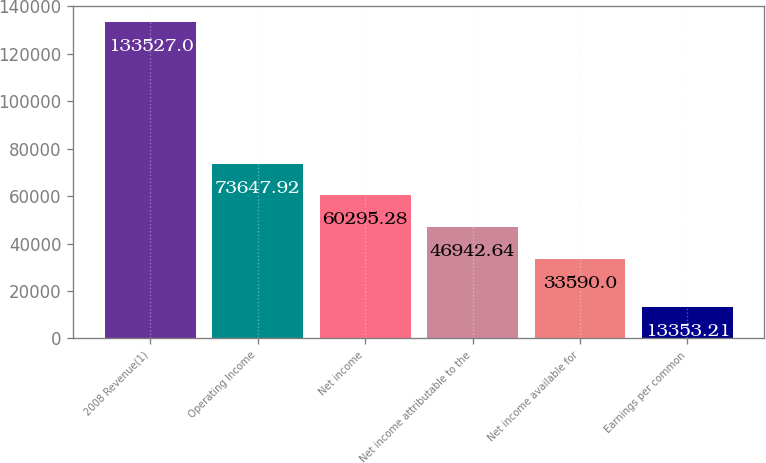Convert chart. <chart><loc_0><loc_0><loc_500><loc_500><bar_chart><fcel>2008 Revenue(1)<fcel>Operating Income<fcel>Net income<fcel>Net income attributable to the<fcel>Net income available for<fcel>Earnings per common<nl><fcel>133527<fcel>73647.9<fcel>60295.3<fcel>46942.6<fcel>33590<fcel>13353.2<nl></chart> 